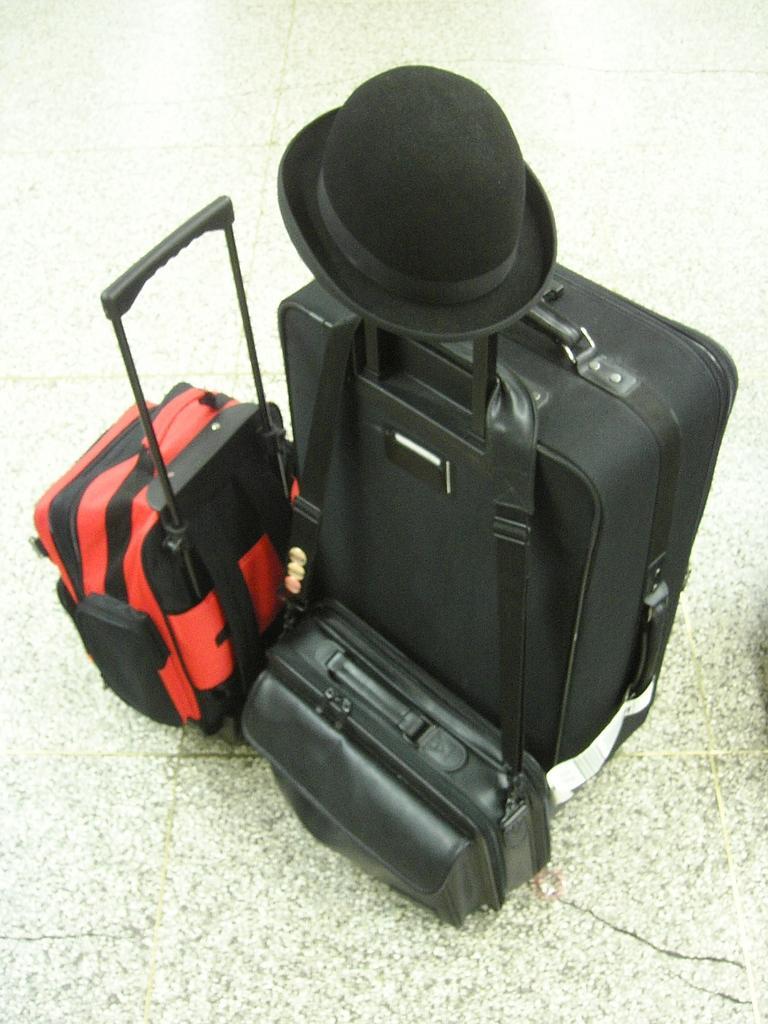Please provide a concise description of this image. We can see luggage bags,hand bag on the floor and we can see cap on the luggage bag. 